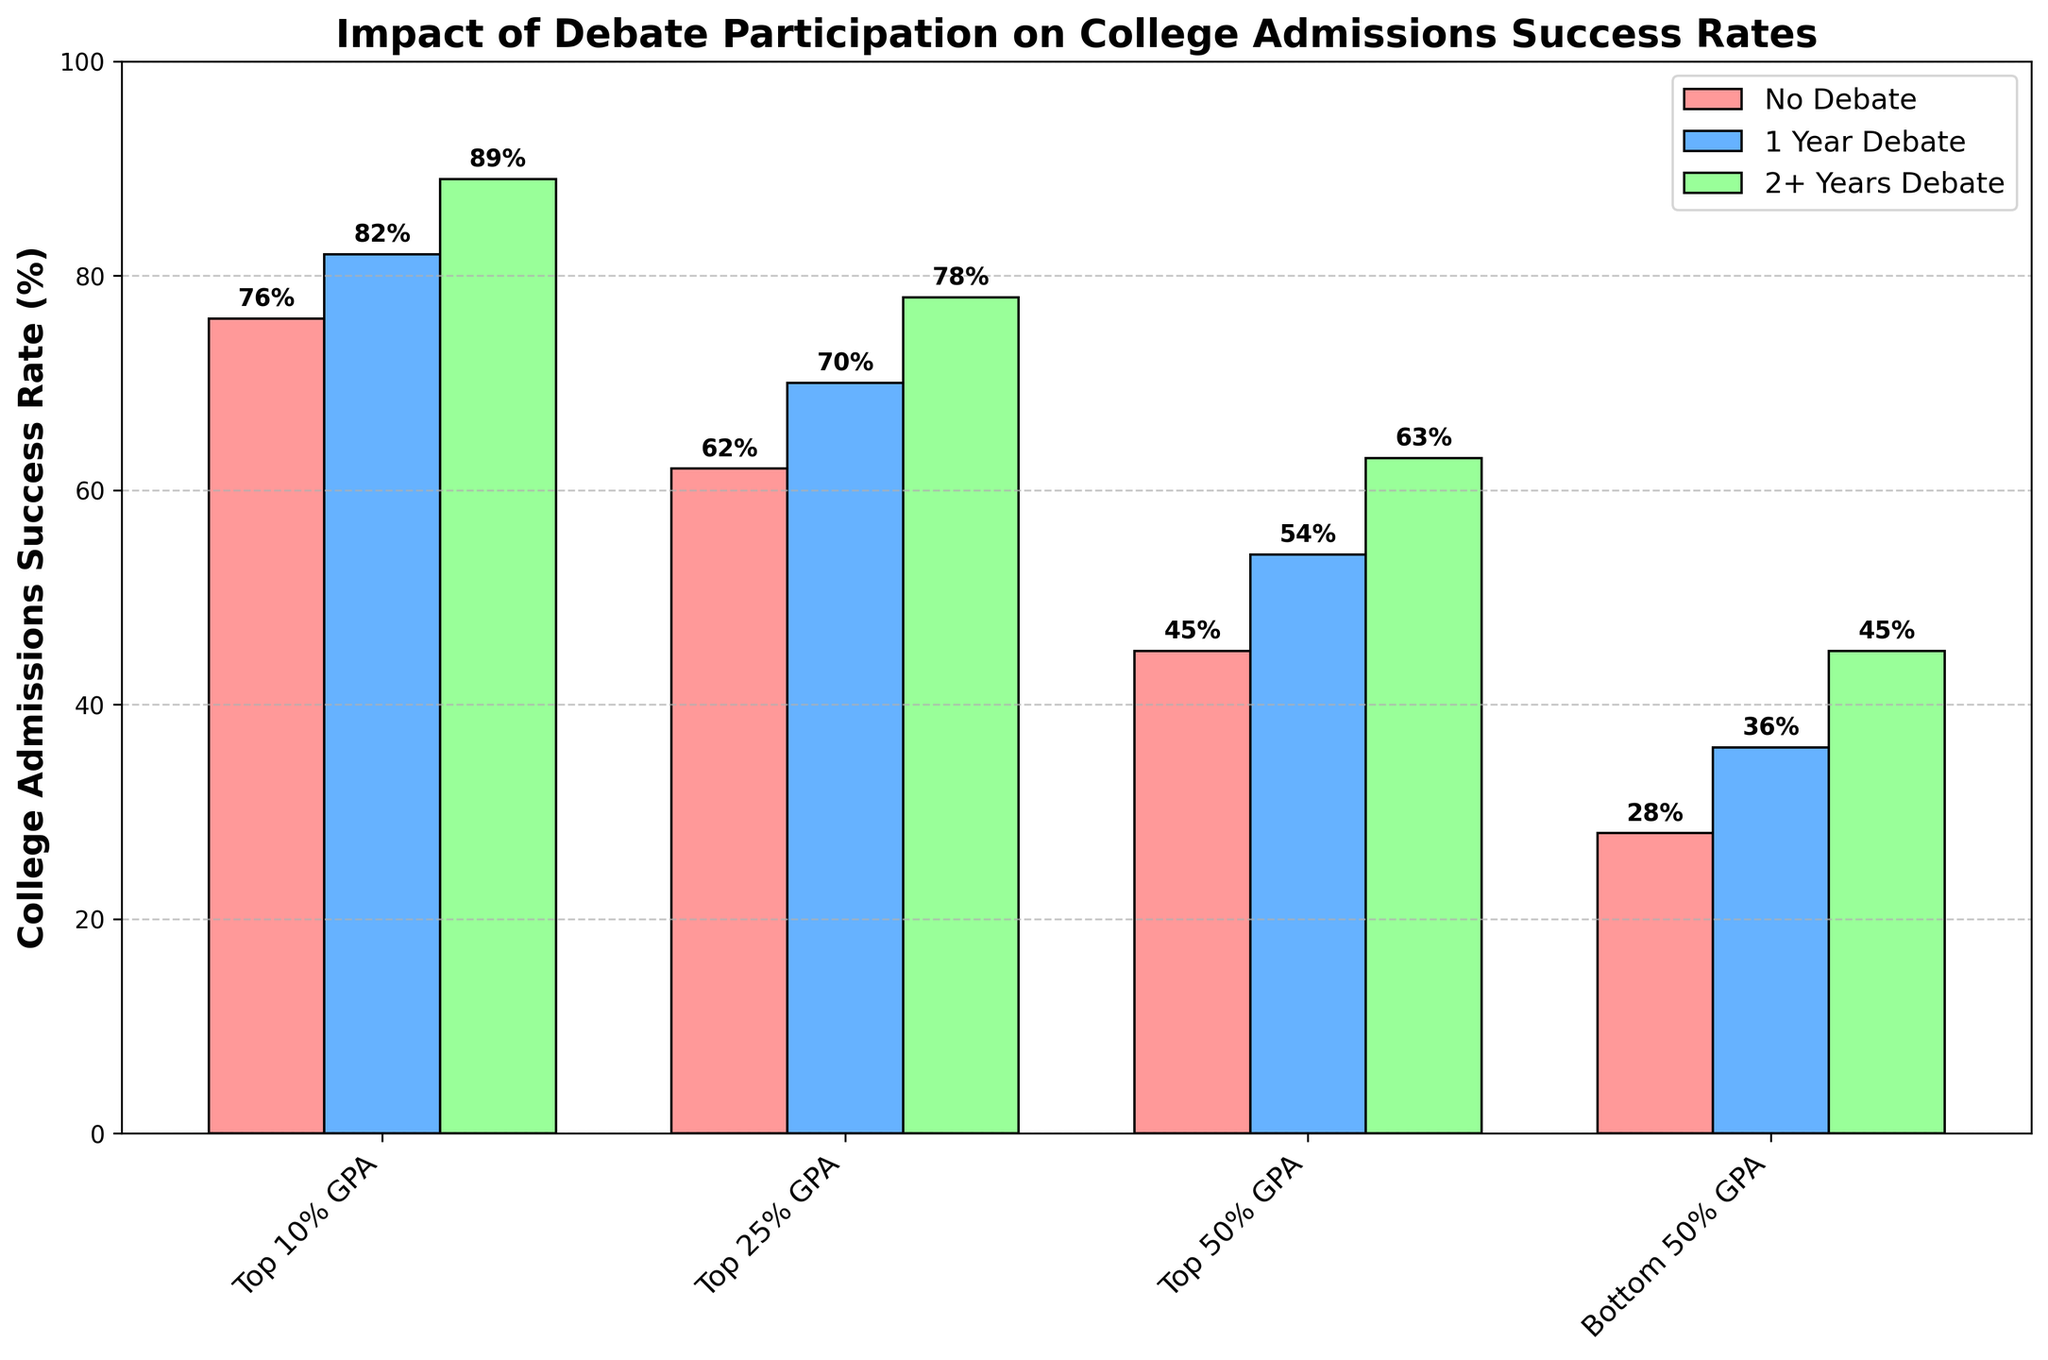What is the college admissions success rate for students in the top 10% GPA who participated in debate for 2+ years? Look at the heights of the green bars within the "Top 10% GPA" category and find that it corresponds to 89%.
Answer: 89% How much higher is the college admissions success rate for students with 1 year of debate experience compared to those with no debate experience in the top 50% GPA? Find the heights of the blue and red bars within the "Top 50% GPA" category: blue bar corresponds to 54% and red bar corresponds to 45%. Subtract the latter from the former: 54% - 45% = 9%.
Answer: 9% What is the average college admissions success rate for students in the bottom 50% GPA who participated in debate for both 1 year and 2+ years? Look at the heights of the blue and green bars within the "Bottom 50% GPA" category: blue is 36% and green is 45%. Calculate the average (36% + 45%) / 2 = 40.5%.
Answer: 40.5% Which academic achievement level shows the smallest difference in college admissions success rate between students who did and did not participate in debate for 1 year? Compare the differences for each category: Top 10% GPA: 82% - 76% = 6%, Top 25% GPA: 70% - 62% = 8%, Top 50% GPA: 54% - 45% = 9%, Bottom 50% GPA: 36% - 28% = 8%. The smallest difference is 6% for the "Top 10% GPA" category.
Answer: Top 10% GPA Which category has the highest admissions success rate with no debate participation? Look at the red bars and identify the highest one. The highest red bar is at 76% in the "Top 10% GPA" category.
Answer: Top 10% GPA In terms of visual height, how does the bar representing 2+ years of debate in the Top 10% GPA group compare to the bar representing no debate participation in the Bottom 50% GPA group? The green bar in the "Top 10% GPA" category is notably taller than the red bar in the "Bottom 50% GPA" category.
Answer: Taller What is the sum of the college admissions success rates for students in the Top 25% GPA who participated in debate for 1 year and 2+ years? Look at the heights of the blue and green bars within the "Top 25% GPA" category: blue is 70% and green is 78%. Calculate the sum: 70% + 78% = 148%.
Answer: 148% Out of all groups, which shows the greatest increase in admissions success rate from no debate participation to 2+ years debate participation? Calculate the increase for each group: Top 10% GPA: 89% - 76% = 13%, Top 25% GPA: 78% - 62% = 16%, Top 50% GPA: 63% - 45% = 18%, Bottom 50% GPA: 45% - 28% = 17%. The greatest increase is in the "Top 50% GPA" group with 18%.
Answer: Top 50% GPA 